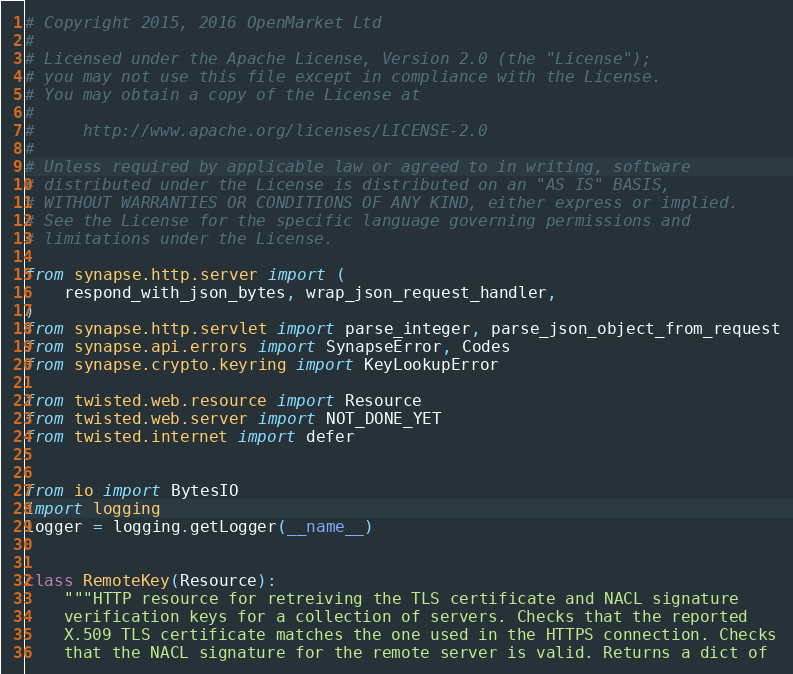<code> <loc_0><loc_0><loc_500><loc_500><_Python_># Copyright 2015, 2016 OpenMarket Ltd
#
# Licensed under the Apache License, Version 2.0 (the "License");
# you may not use this file except in compliance with the License.
# You may obtain a copy of the License at
#
#     http://www.apache.org/licenses/LICENSE-2.0
#
# Unless required by applicable law or agreed to in writing, software
# distributed under the License is distributed on an "AS IS" BASIS,
# WITHOUT WARRANTIES OR CONDITIONS OF ANY KIND, either express or implied.
# See the License for the specific language governing permissions and
# limitations under the License.

from synapse.http.server import (
    respond_with_json_bytes, wrap_json_request_handler,
)
from synapse.http.servlet import parse_integer, parse_json_object_from_request
from synapse.api.errors import SynapseError, Codes
from synapse.crypto.keyring import KeyLookupError

from twisted.web.resource import Resource
from twisted.web.server import NOT_DONE_YET
from twisted.internet import defer


from io import BytesIO
import logging
logger = logging.getLogger(__name__)


class RemoteKey(Resource):
    """HTTP resource for retreiving the TLS certificate and NACL signature
    verification keys for a collection of servers. Checks that the reported
    X.509 TLS certificate matches the one used in the HTTPS connection. Checks
    that the NACL signature for the remote server is valid. Returns a dict of</code> 